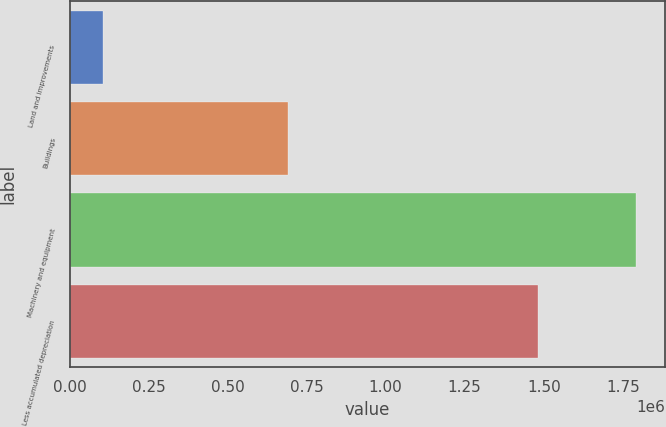<chart> <loc_0><loc_0><loc_500><loc_500><bar_chart><fcel>Land and improvements<fcel>Buildings<fcel>Machinery and equipment<fcel>Less accumulated depreciation<nl><fcel>106472<fcel>691766<fcel>1.79362e+06<fcel>1.4832e+06<nl></chart> 